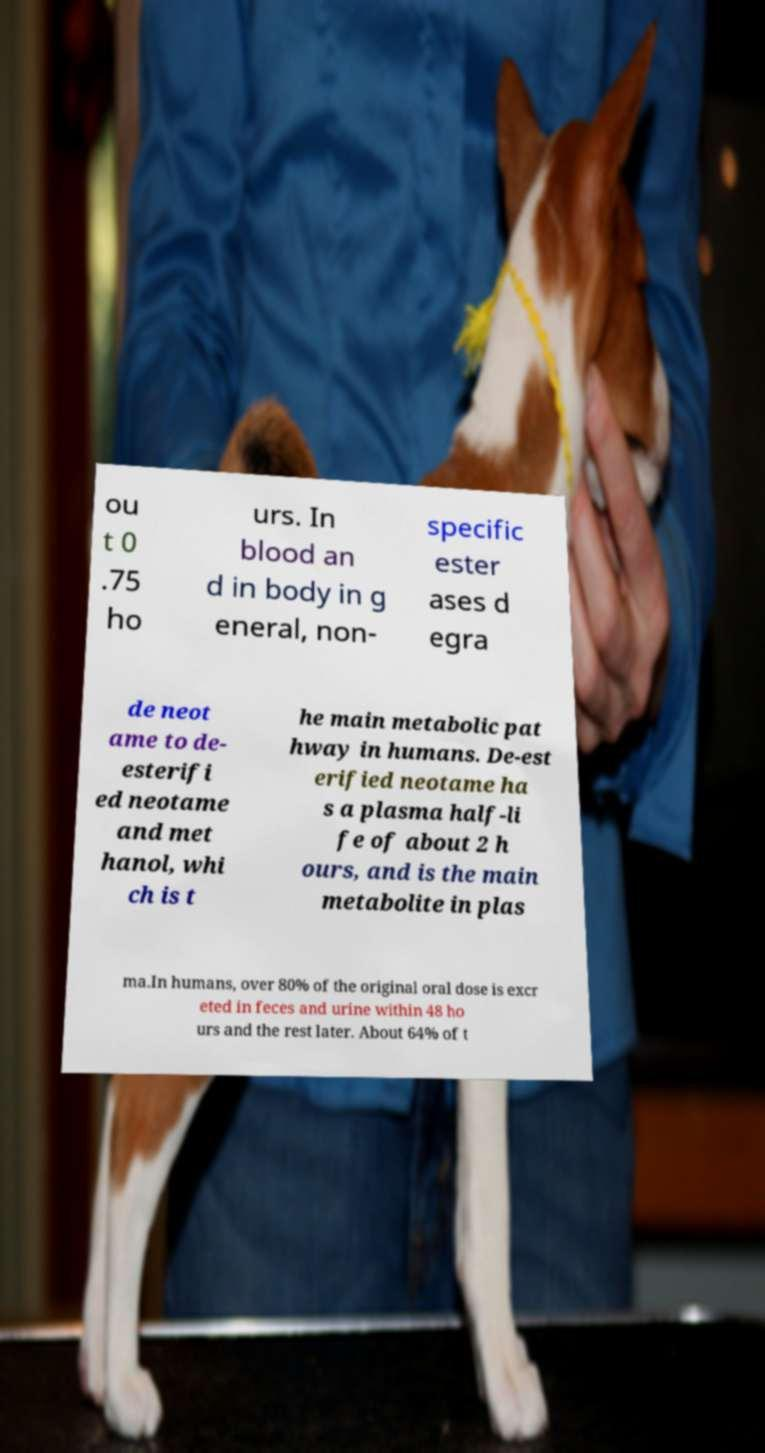What messages or text are displayed in this image? I need them in a readable, typed format. ou t 0 .75 ho urs. In blood an d in body in g eneral, non- specific ester ases d egra de neot ame to de- esterifi ed neotame and met hanol, whi ch is t he main metabolic pat hway in humans. De-est erified neotame ha s a plasma half-li fe of about 2 h ours, and is the main metabolite in plas ma.In humans, over 80% of the original oral dose is excr eted in feces and urine within 48 ho urs and the rest later. About 64% of t 